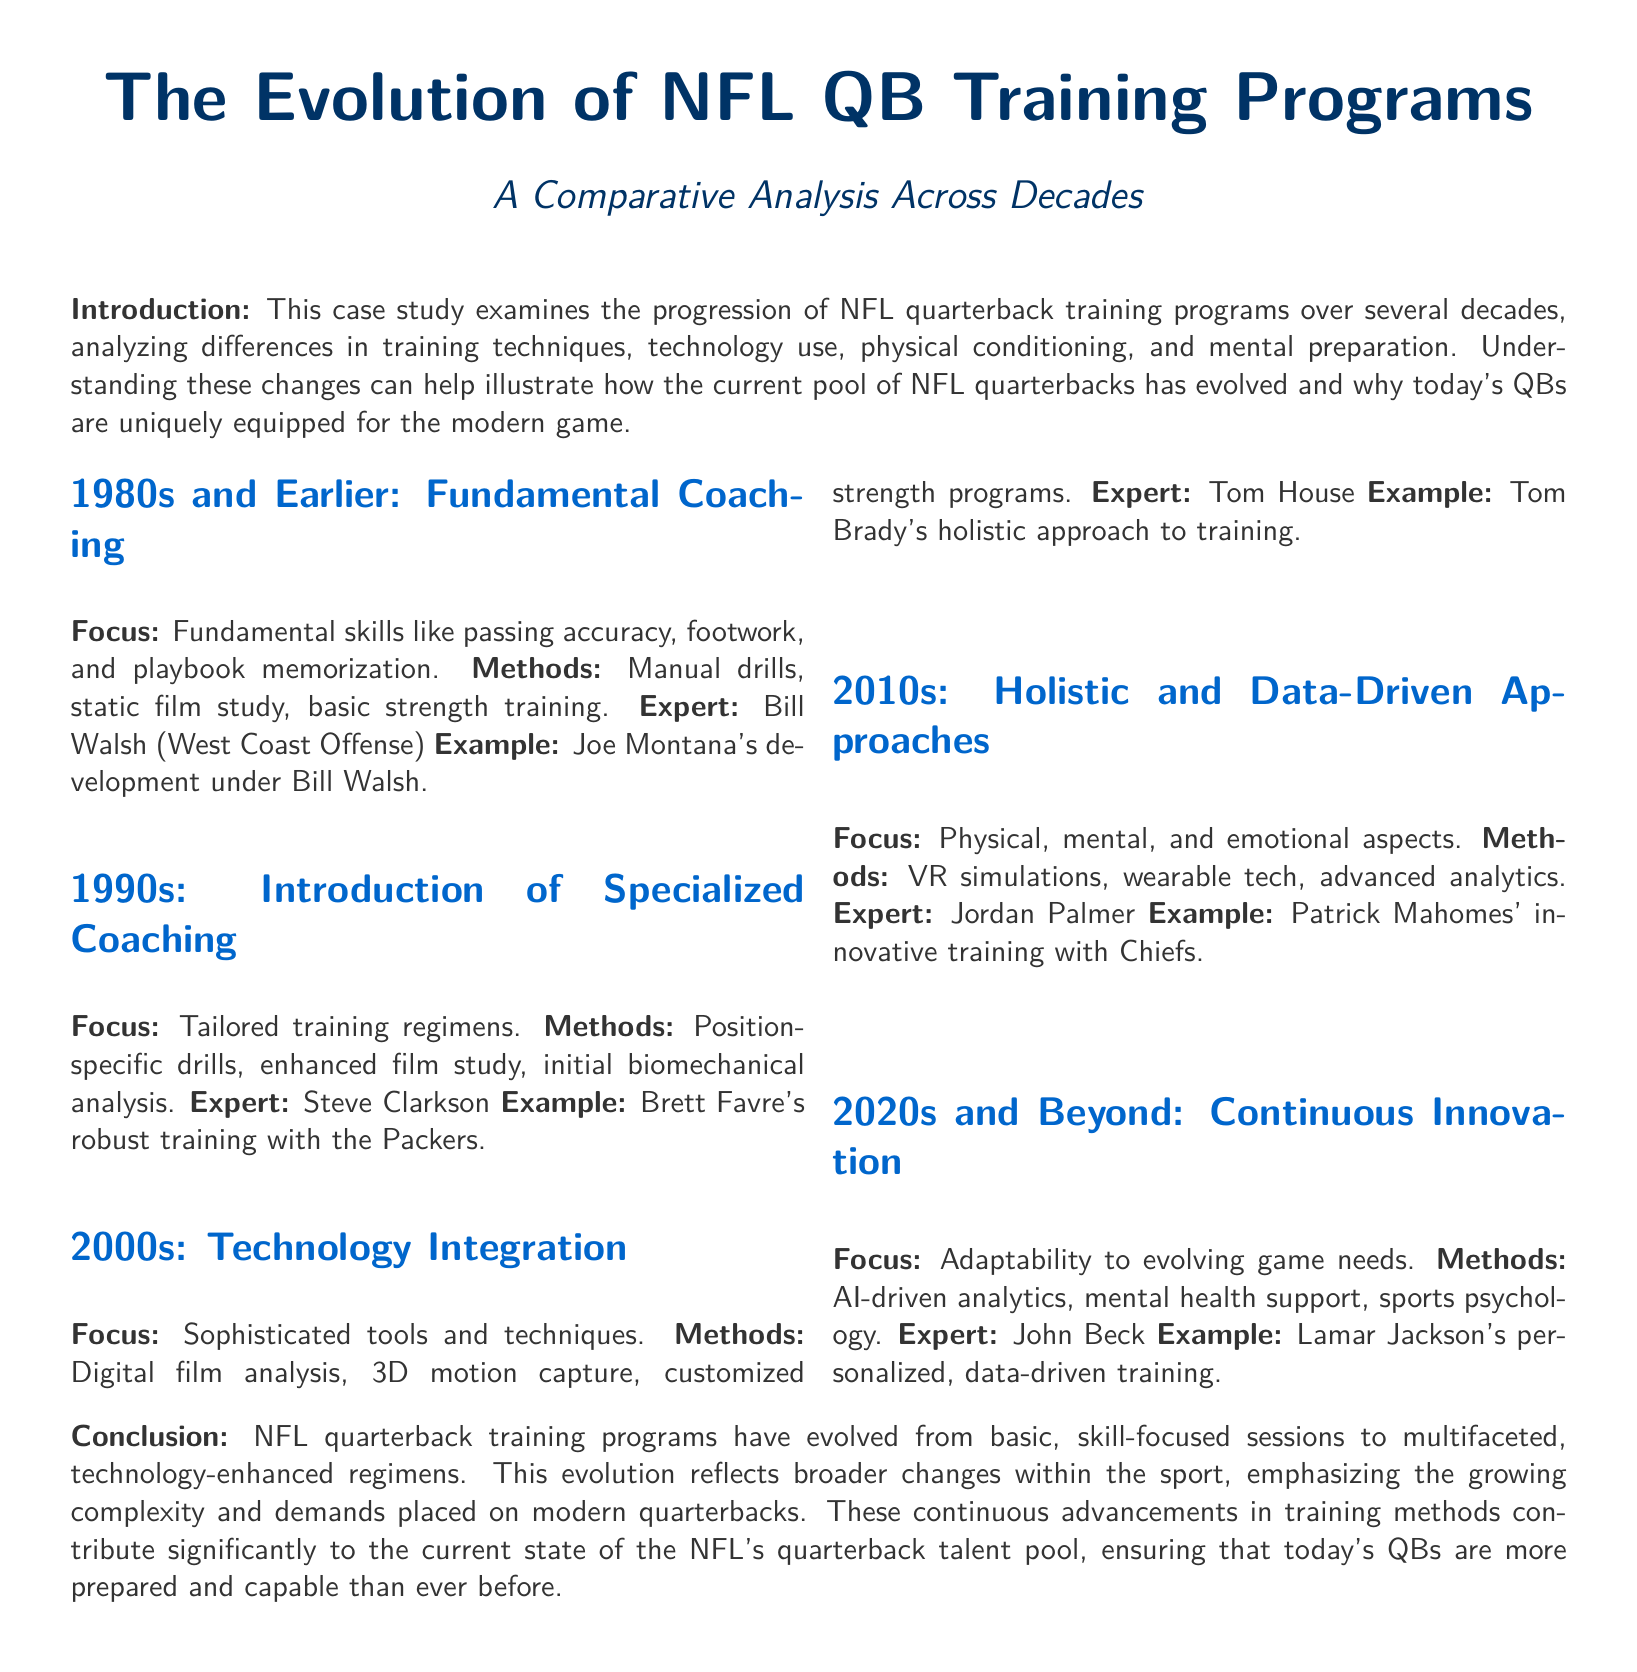What was the focus of NFL QB training in the 1980s? The focus in the 1980s was on fundamental skills like passing accuracy, footwork, and playbook memorization.
Answer: Fundamental skills Who was an expert associated with the training methods in the 1990s? The document states that Steve Clarkson was an expert associated with the training methods in the 1990s.
Answer: Steve Clarkson What training method was introduced in the 2000s? The 2000s saw the introduction of digital film analysis as a training method.
Answer: Digital film analysis Which NFL quarterback is noted for innovative training in the 2010s? Patrick Mahomes is mentioned for his innovative training in the 2010s.
Answer: Patrick Mahomes What does the conclusion highlight about modern NFL quarterbacks? The conclusion highlights that modern NFL quarterbacks are more prepared and capable than ever before.
Answer: More prepared and capable What is a key technological advancement in the 2020s training programs? AI-driven analytics is noted as a key technological advancement in the 2020s training programs.
Answer: AI-driven analytics Which decade emphasized mental health support in QB training? The document indicates that the 2020s emphasized mental health support in QB training.
Answer: 2020s What example is provided for the training of a quarterback in the 2000s? The example provided for the training of a quarterback in the 2000s is Tom Brady.
Answer: Tom Brady Who was the expert associated with training programs in the 2020s? John Beck is identified as the expert associated with training programs in the 2020s.
Answer: John Beck 